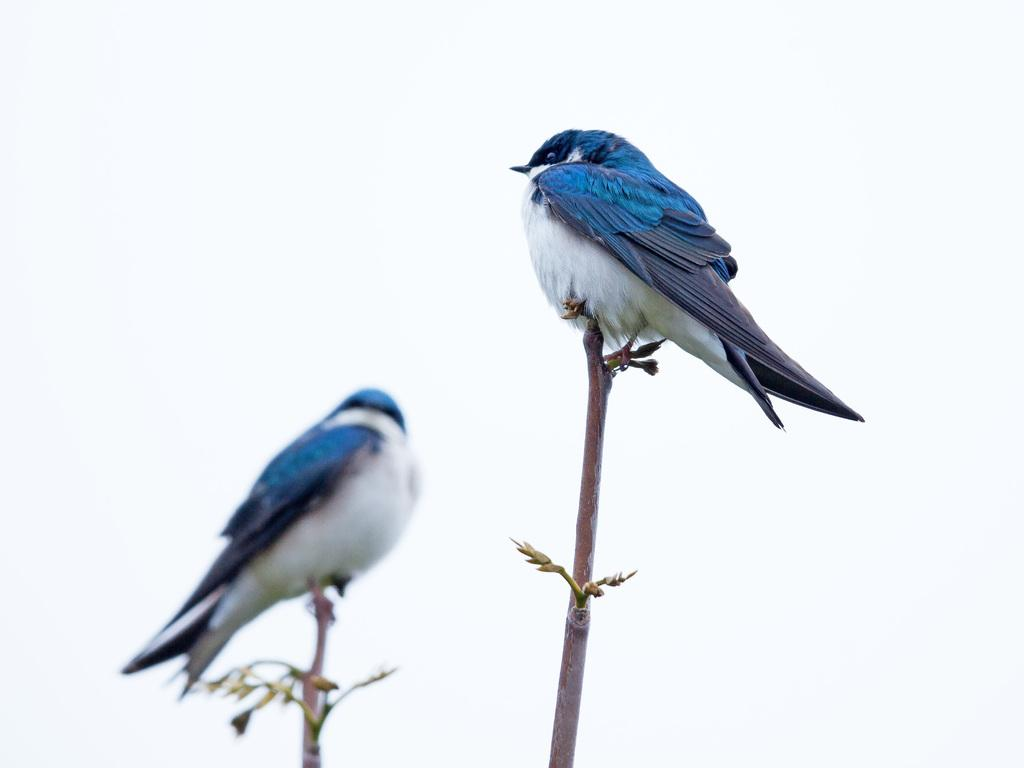What type of animals can be seen in the image? There are birds in the image. Where are the birds located in the image? The birds are on branches. What colors can be observed on the birds? The birds have white, blue, and black colors. What is the color of the background in the image? The background of the image is white. What type of band can be heard playing in the image? There is no band present in the image, as it features birds on branches with a white background. 